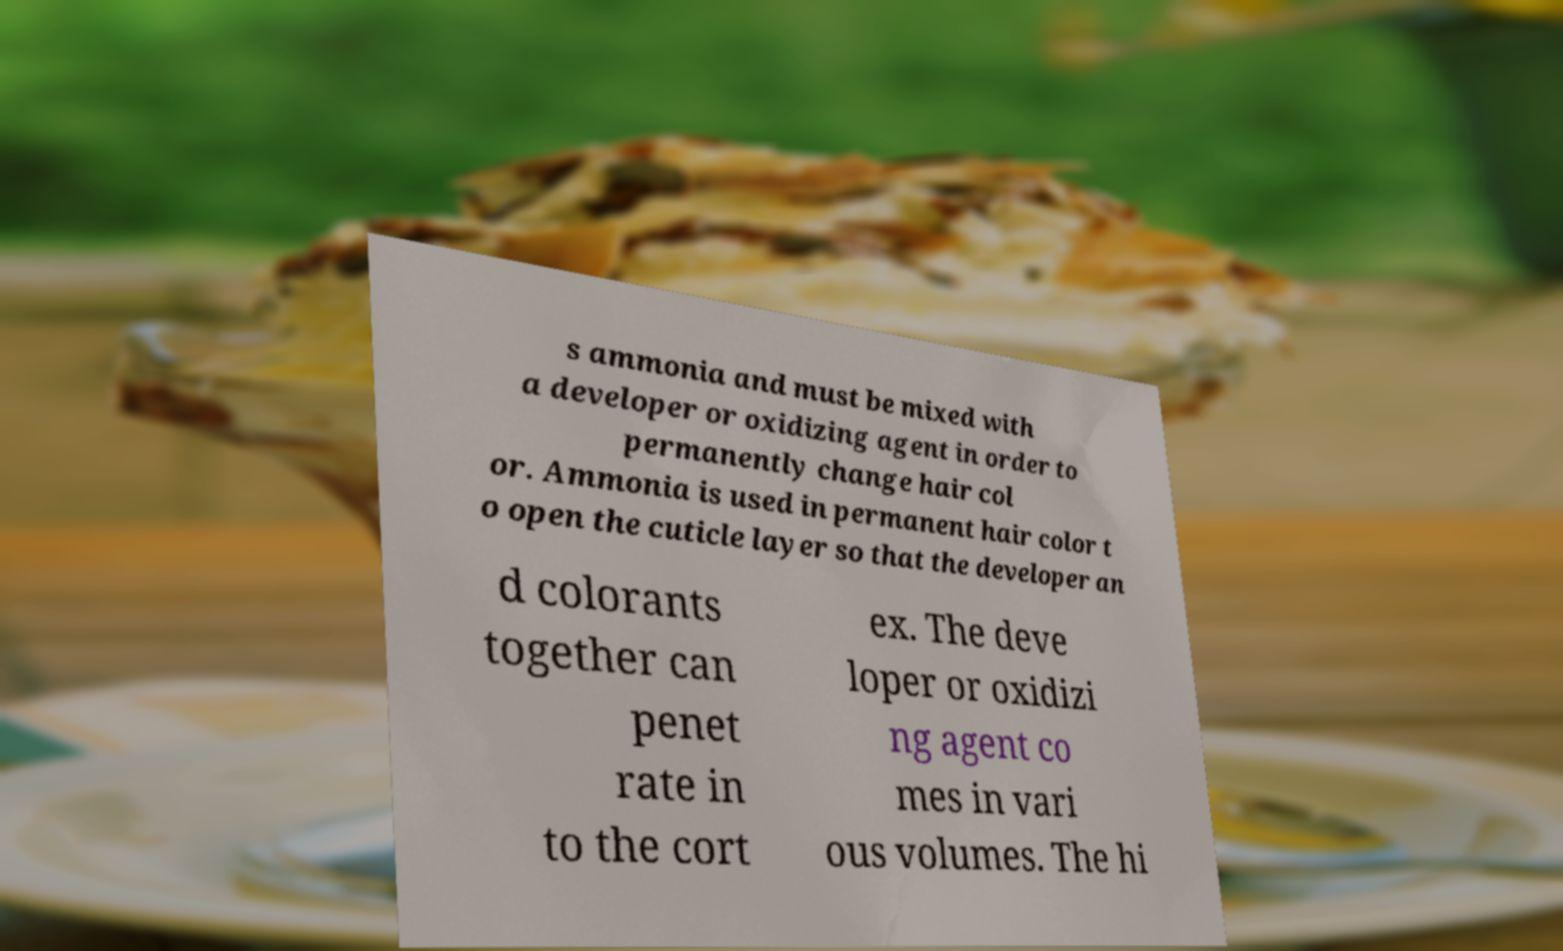What messages or text are displayed in this image? I need them in a readable, typed format. s ammonia and must be mixed with a developer or oxidizing agent in order to permanently change hair col or. Ammonia is used in permanent hair color t o open the cuticle layer so that the developer an d colorants together can penet rate in to the cort ex. The deve loper or oxidizi ng agent co mes in vari ous volumes. The hi 